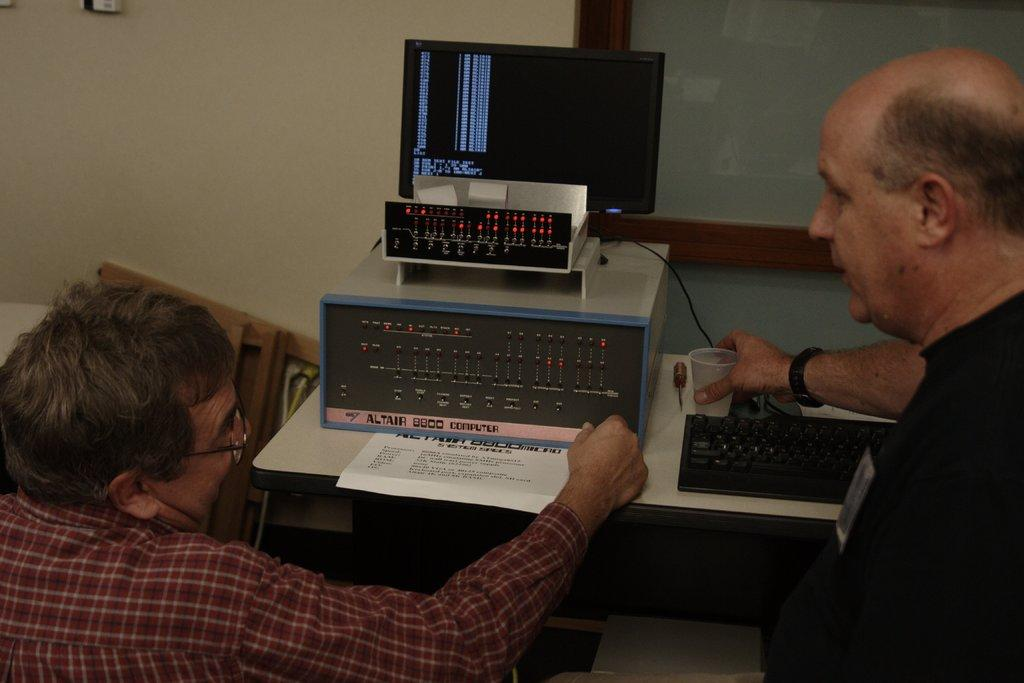<image>
Create a compact narrative representing the image presented. Two men sit in front of an Altair 8800 Computer. 